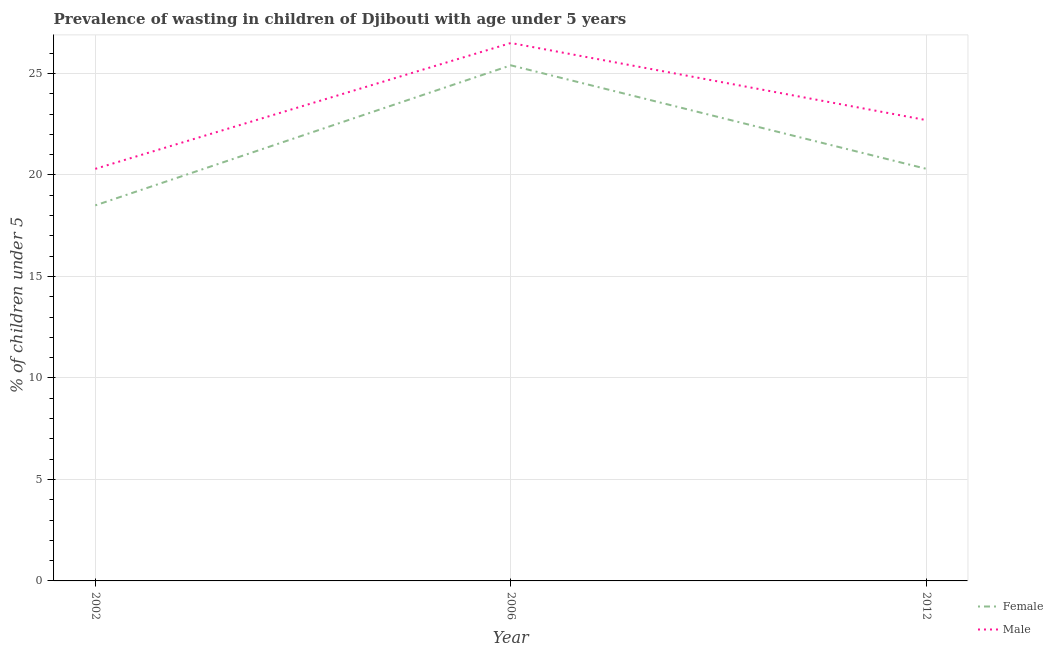How many different coloured lines are there?
Provide a short and direct response. 2. Across all years, what is the maximum percentage of undernourished male children?
Your answer should be compact. 26.5. Across all years, what is the minimum percentage of undernourished male children?
Keep it short and to the point. 20.3. In which year was the percentage of undernourished female children maximum?
Keep it short and to the point. 2006. What is the total percentage of undernourished male children in the graph?
Provide a succinct answer. 69.5. What is the difference between the percentage of undernourished male children in 2002 and that in 2006?
Your answer should be compact. -6.2. What is the difference between the percentage of undernourished female children in 2006 and the percentage of undernourished male children in 2002?
Ensure brevity in your answer.  5.1. What is the average percentage of undernourished male children per year?
Offer a very short reply. 23.17. In the year 2012, what is the difference between the percentage of undernourished female children and percentage of undernourished male children?
Your answer should be very brief. -2.4. What is the ratio of the percentage of undernourished male children in 2002 to that in 2012?
Your response must be concise. 0.89. Is the difference between the percentage of undernourished female children in 2002 and 2006 greater than the difference between the percentage of undernourished male children in 2002 and 2006?
Keep it short and to the point. No. What is the difference between the highest and the second highest percentage of undernourished female children?
Offer a terse response. 5.1. What is the difference between the highest and the lowest percentage of undernourished female children?
Provide a short and direct response. 6.9. In how many years, is the percentage of undernourished male children greater than the average percentage of undernourished male children taken over all years?
Your response must be concise. 1. Is the sum of the percentage of undernourished female children in 2006 and 2012 greater than the maximum percentage of undernourished male children across all years?
Make the answer very short. Yes. How many years are there in the graph?
Provide a short and direct response. 3. Are the values on the major ticks of Y-axis written in scientific E-notation?
Offer a very short reply. No. Where does the legend appear in the graph?
Make the answer very short. Bottom right. How many legend labels are there?
Your answer should be very brief. 2. How are the legend labels stacked?
Give a very brief answer. Vertical. What is the title of the graph?
Provide a short and direct response. Prevalence of wasting in children of Djibouti with age under 5 years. What is the label or title of the X-axis?
Your answer should be very brief. Year. What is the label or title of the Y-axis?
Offer a very short reply.  % of children under 5. What is the  % of children under 5 of Female in 2002?
Provide a short and direct response. 18.5. What is the  % of children under 5 in Male in 2002?
Offer a terse response. 20.3. What is the  % of children under 5 in Female in 2006?
Your response must be concise. 25.4. What is the  % of children under 5 in Female in 2012?
Provide a succinct answer. 20.3. What is the  % of children under 5 in Male in 2012?
Offer a very short reply. 22.7. Across all years, what is the maximum  % of children under 5 in Female?
Your response must be concise. 25.4. Across all years, what is the maximum  % of children under 5 in Male?
Ensure brevity in your answer.  26.5. Across all years, what is the minimum  % of children under 5 of Male?
Your answer should be very brief. 20.3. What is the total  % of children under 5 in Female in the graph?
Make the answer very short. 64.2. What is the total  % of children under 5 of Male in the graph?
Offer a very short reply. 69.5. What is the difference between the  % of children under 5 of Female in 2006 and that in 2012?
Make the answer very short. 5.1. What is the difference between the  % of children under 5 of Male in 2006 and that in 2012?
Make the answer very short. 3.8. What is the difference between the  % of children under 5 of Female in 2002 and the  % of children under 5 of Male in 2006?
Make the answer very short. -8. What is the difference between the  % of children under 5 in Female in 2002 and the  % of children under 5 in Male in 2012?
Keep it short and to the point. -4.2. What is the average  % of children under 5 in Female per year?
Ensure brevity in your answer.  21.4. What is the average  % of children under 5 in Male per year?
Your answer should be very brief. 23.17. In the year 2012, what is the difference between the  % of children under 5 of Female and  % of children under 5 of Male?
Provide a short and direct response. -2.4. What is the ratio of the  % of children under 5 in Female in 2002 to that in 2006?
Give a very brief answer. 0.73. What is the ratio of the  % of children under 5 in Male in 2002 to that in 2006?
Ensure brevity in your answer.  0.77. What is the ratio of the  % of children under 5 in Female in 2002 to that in 2012?
Make the answer very short. 0.91. What is the ratio of the  % of children under 5 of Male in 2002 to that in 2012?
Your response must be concise. 0.89. What is the ratio of the  % of children under 5 in Female in 2006 to that in 2012?
Keep it short and to the point. 1.25. What is the ratio of the  % of children under 5 in Male in 2006 to that in 2012?
Provide a succinct answer. 1.17. What is the difference between the highest and the second highest  % of children under 5 of Male?
Provide a succinct answer. 3.8. What is the difference between the highest and the lowest  % of children under 5 of Female?
Your answer should be compact. 6.9. 